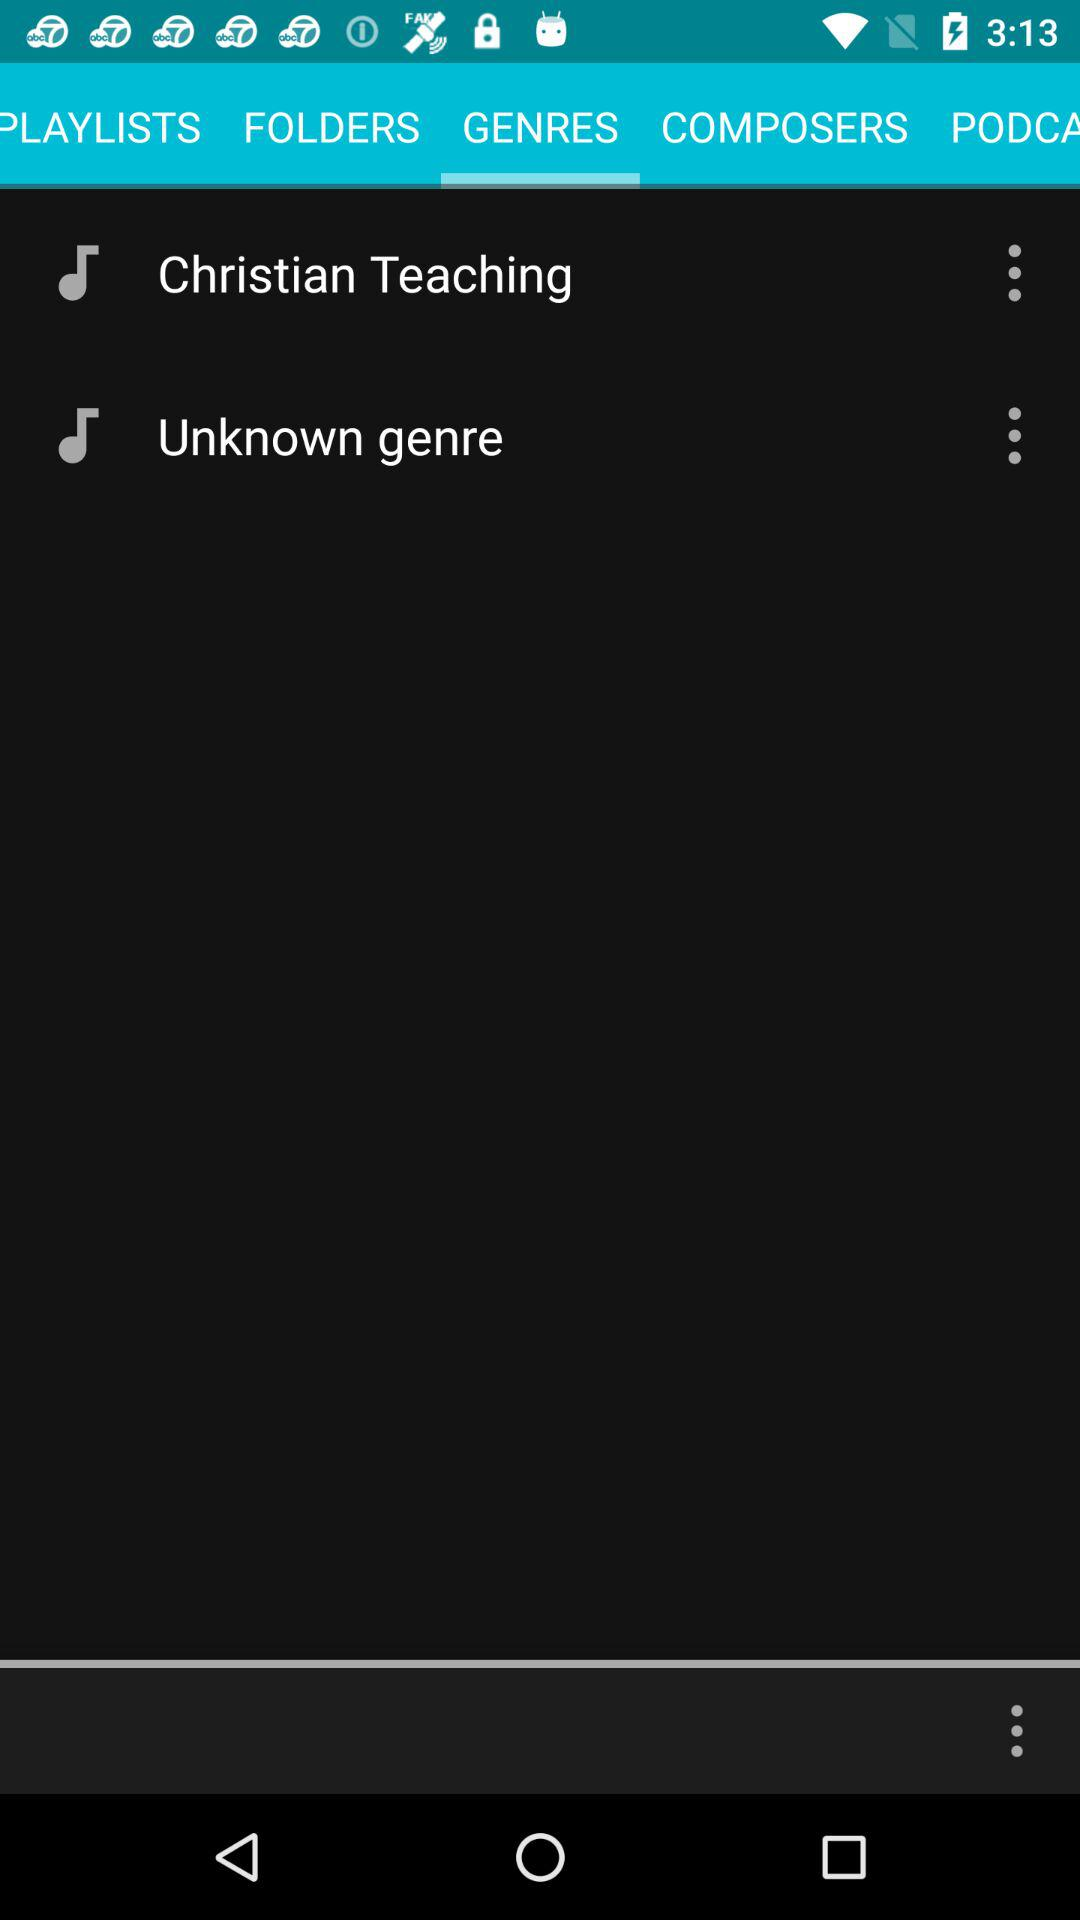Which tab has been selected? The tab "GENRES" has been selected. 